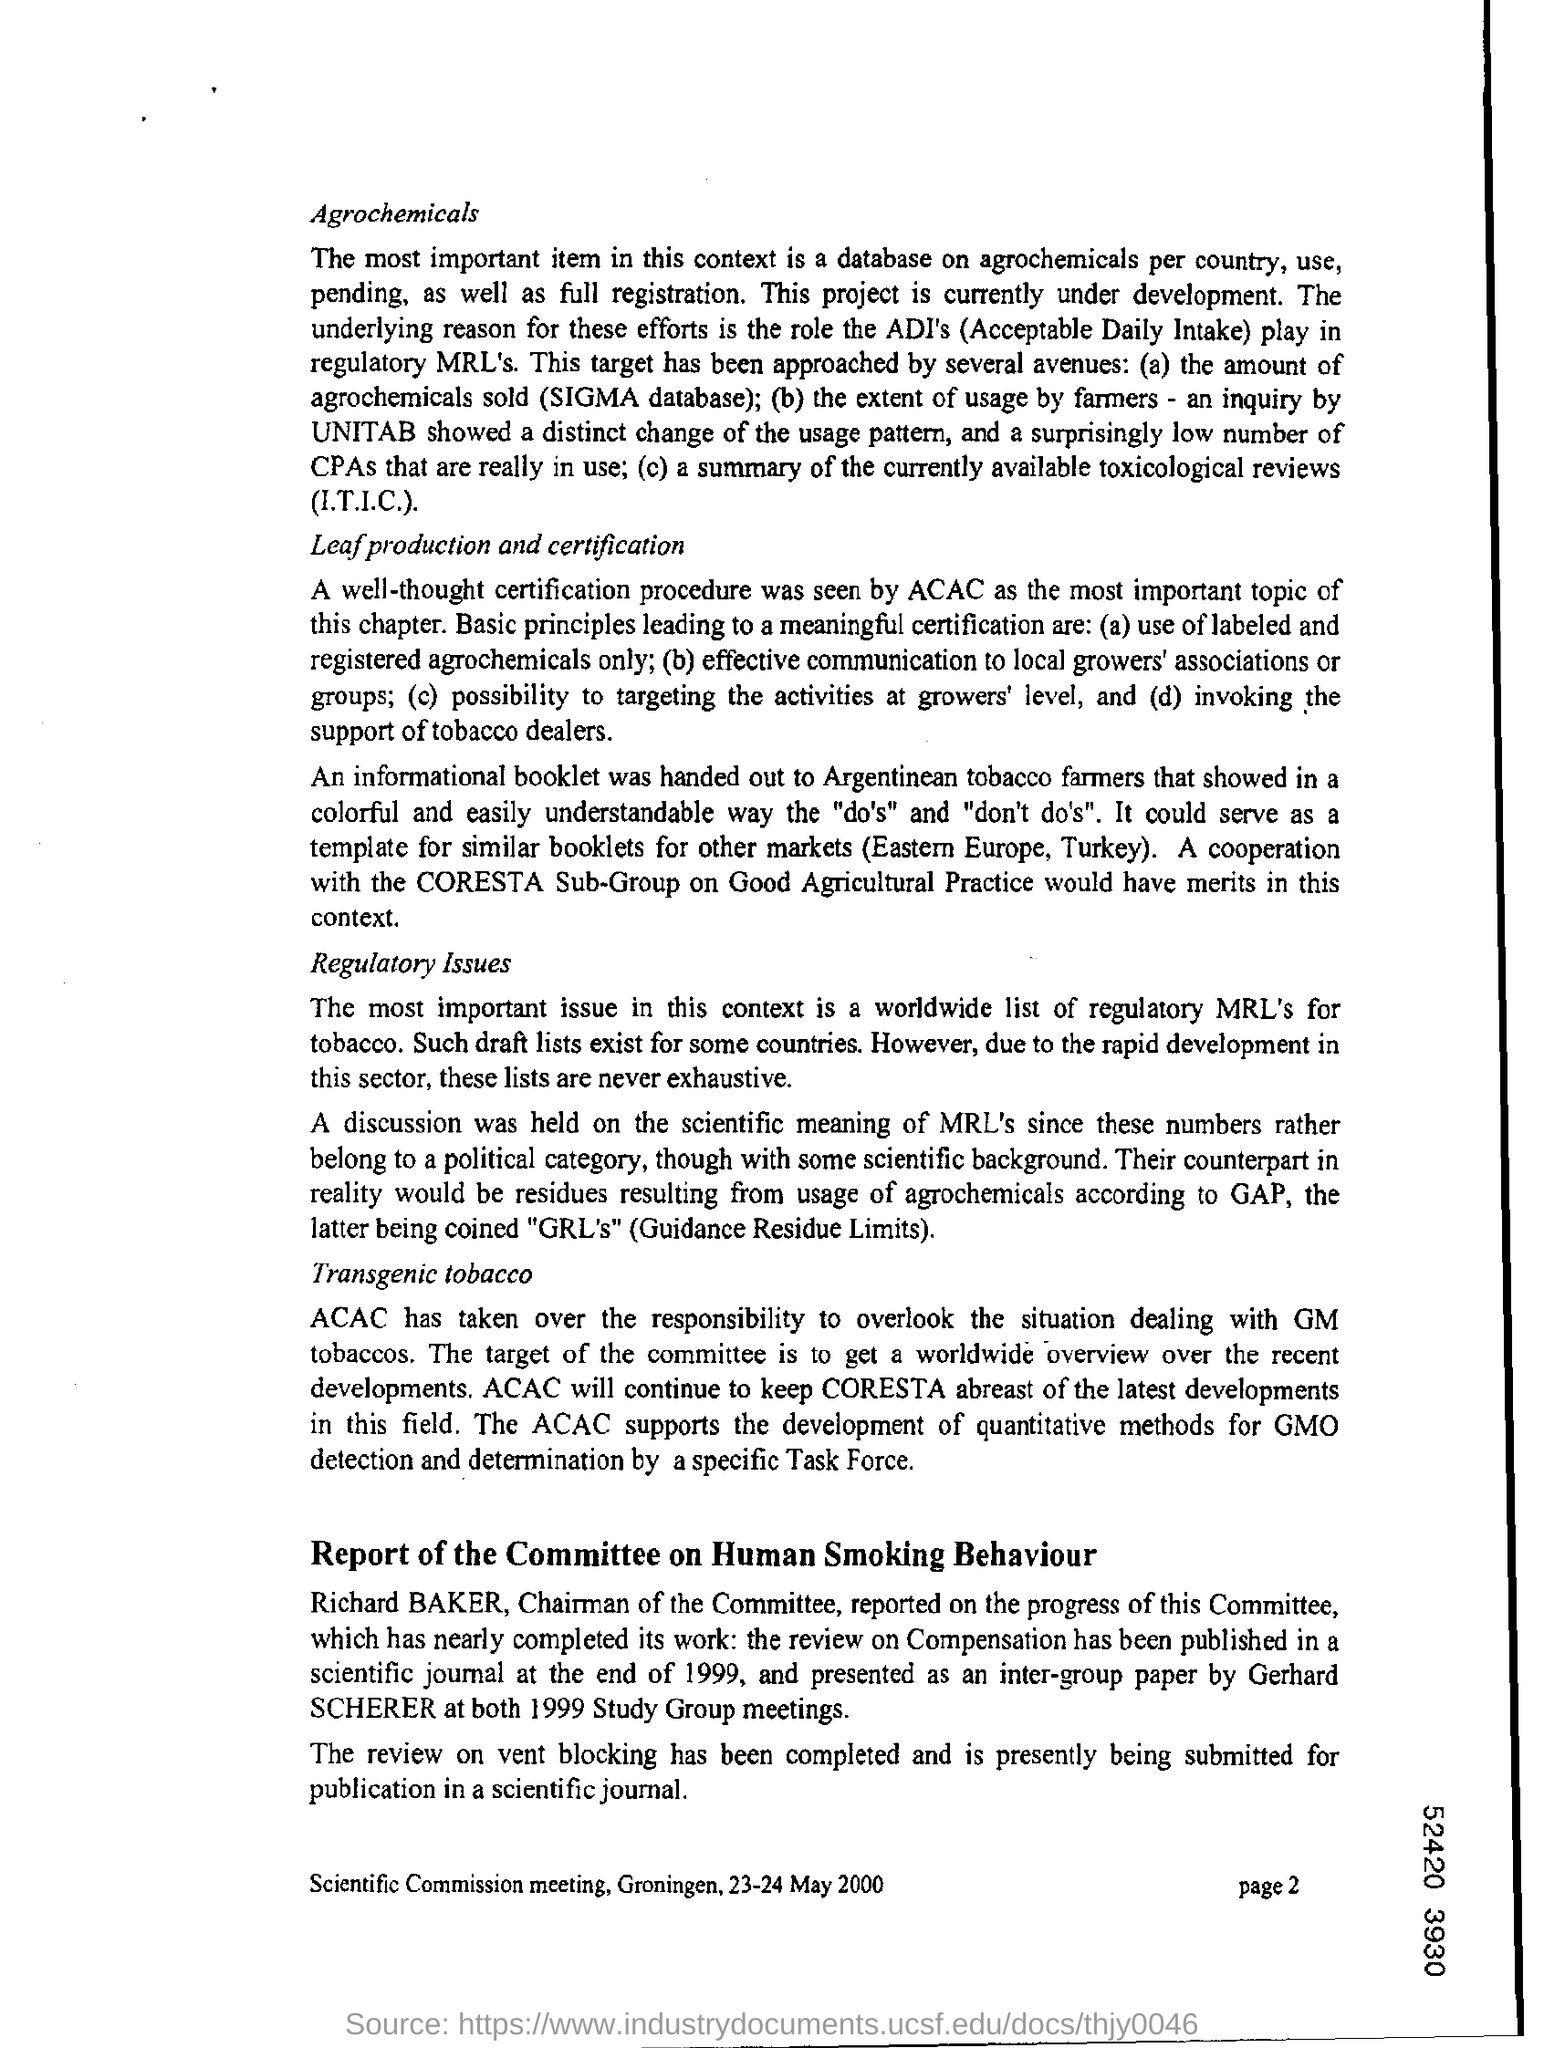Mention the page number at bottom right corner of the page ?
Offer a terse response. Page 2. What is the heading of the first paragraph from top ?
Provide a short and direct response. Agrochemicals. 